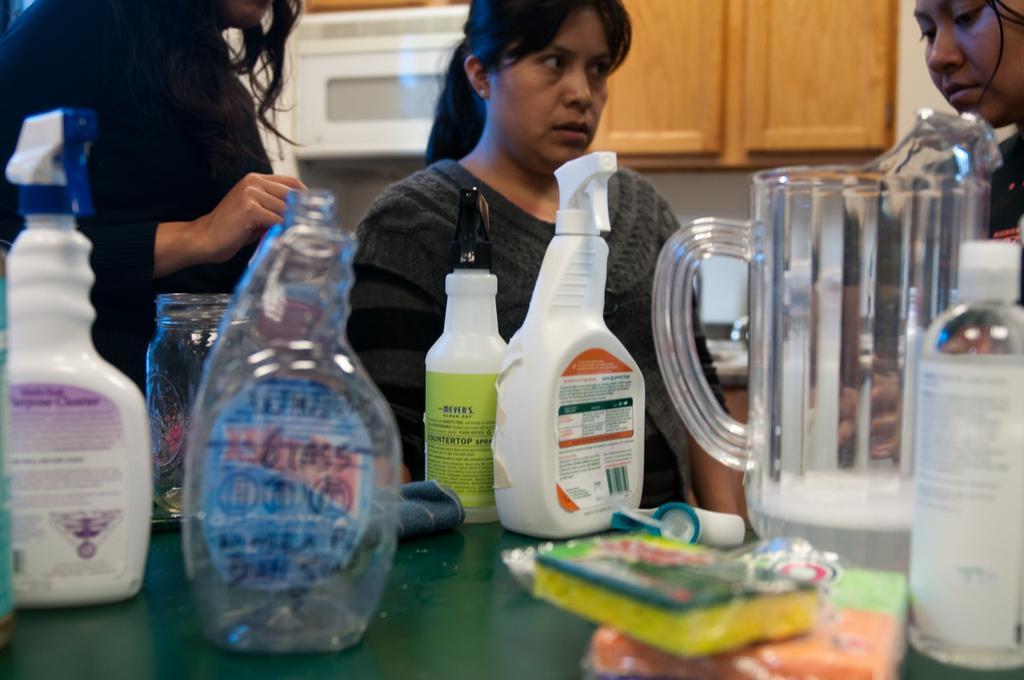How would you summarize this image in a sentence or two? In this image we can see a group of people are standing on the floor, and in front here is the table and jar and some objects on it. 